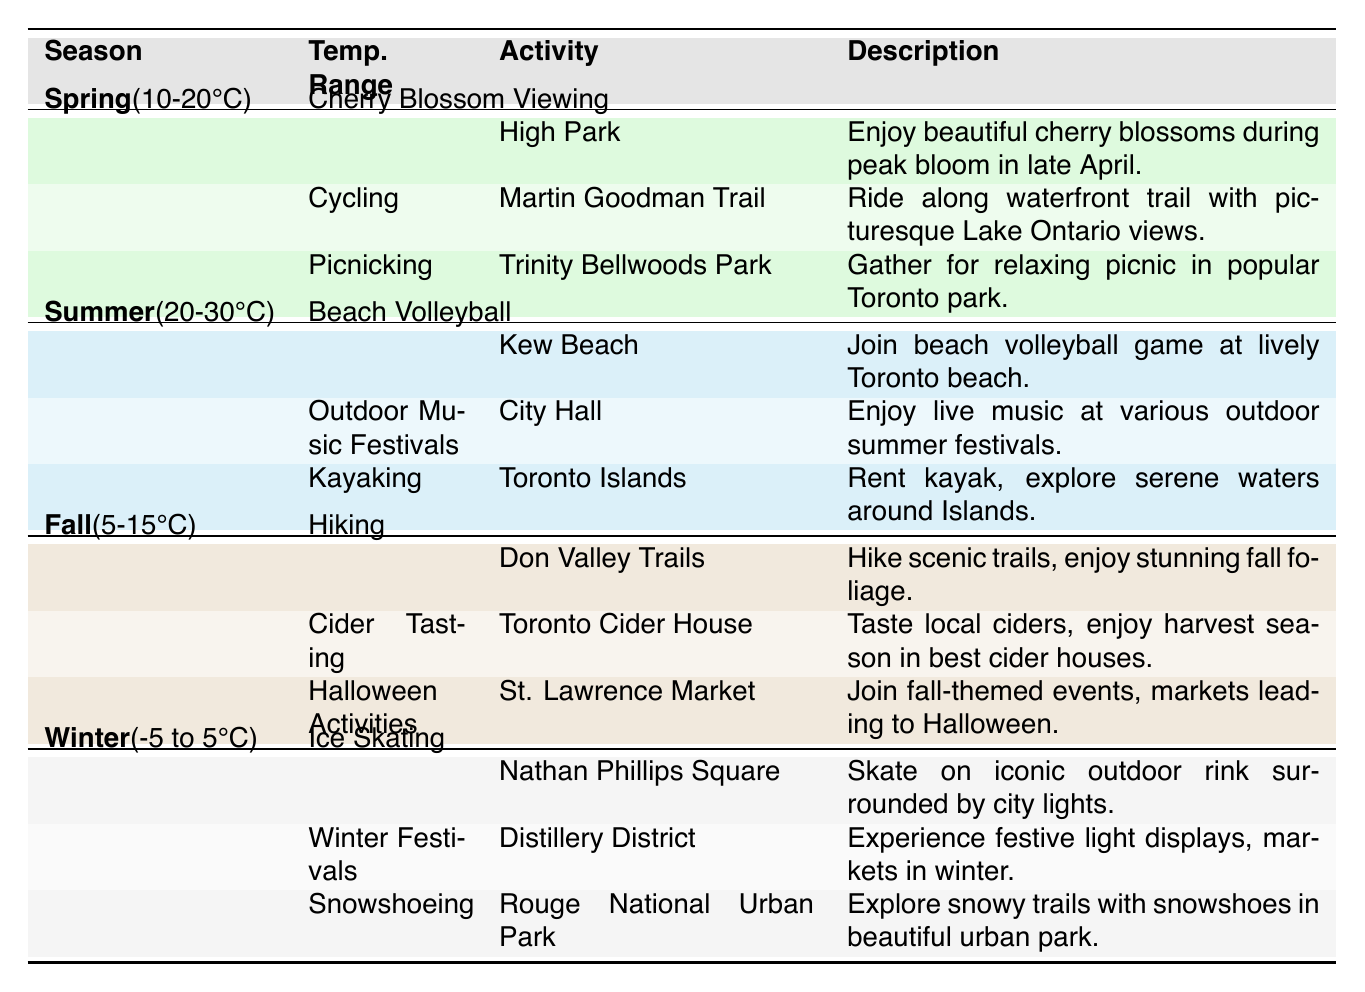What outdoor activity can be enjoyed in Toronto during Spring? The table lists three activities for Spring: Cherry Blossom Viewing, Cycling, and Picnicking. All these activities are highlighted under the Spring section of the table.
Answer: Cherry Blossom Viewing, Cycling, Picnicking Where can you go for Kayaking in Toronto? The activity of Kayaking is listed in the Summer section of the table and specifies the location as Toronto Islands.
Answer: Toronto Islands Is there an outdoor activity that involves ice skating in the Winter? The table includes Ice Skating as an outdoor activity for Winter, indicating it is specifically mentioned under that season.
Answer: Yes What is the temperature range for Fall activities? The Fall section of the table states that the temperature range is 5-15°C, which can be directly retrieved from the table's Fall entry.
Answer: 5-15°C Which activity is available at Nathan Phillips Square during Winter? Looking at the Winter section, Ice Skating is specifically mentioned as the activity available at Nathan Phillips Square during that season.
Answer: Ice Skating How many activities are there for Summer? The Summer section lists three activities: Beach Volleyball, Outdoor Music Festivals, and Kayaking. To find the total, count the listed activities under the Summer heading.
Answer: 3 Are there any activities listed for Cider Tasting in the Winter? By checking the table, Cider Tasting is listed under the Fall section, not Winter, thereby confirming it is not an activity available during Winter.
Answer: No What is the main theme of activities in Fall? Activities in the Fall section focus on nature and seasonal celebrations, reflected in Hiking, Cider Tasting, and Halloween Activities. Thus, the theme revolves around enjoying the outdoors and seasonal festivities in the fall.
Answer: Nature and seasonal celebrations Which season features outdoor music festivals? The Summer section of the table explicitly states that Outdoor Music Festivals are available, which can be pinpointed by checking the activities listed under Summer.
Answer: Summer 